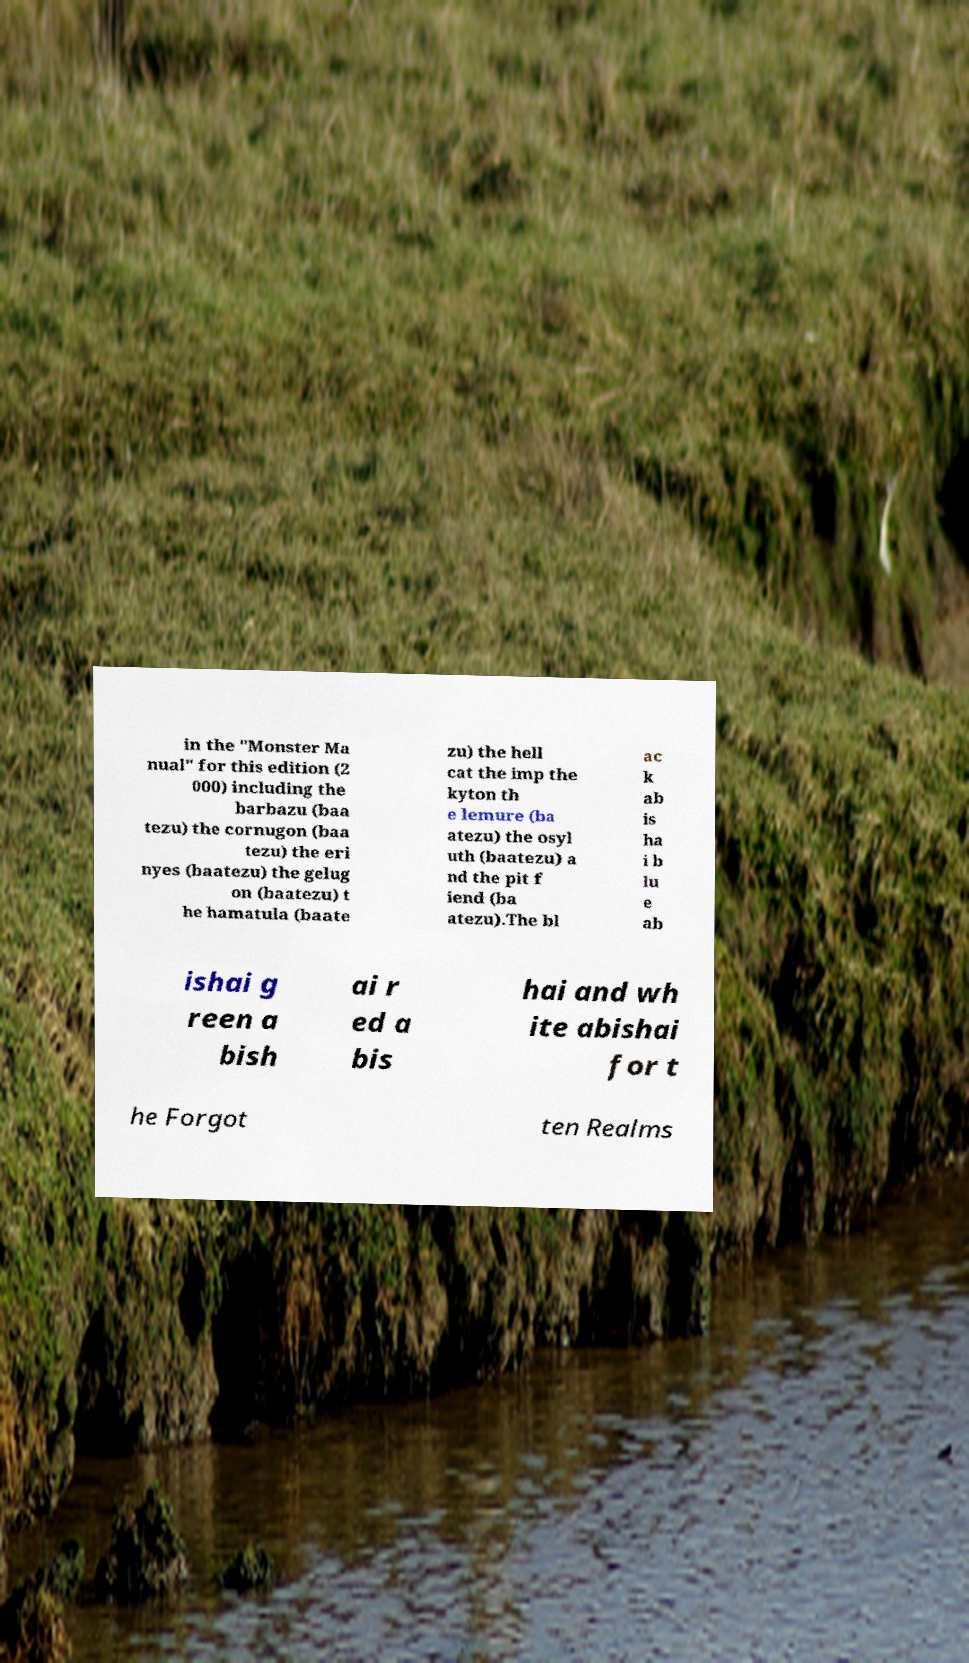Could you extract and type out the text from this image? in the "Monster Ma nual" for this edition (2 000) including the barbazu (baa tezu) the cornugon (baa tezu) the eri nyes (baatezu) the gelug on (baatezu) t he hamatula (baate zu) the hell cat the imp the kyton th e lemure (ba atezu) the osyl uth (baatezu) a nd the pit f iend (ba atezu).The bl ac k ab is ha i b lu e ab ishai g reen a bish ai r ed a bis hai and wh ite abishai for t he Forgot ten Realms 